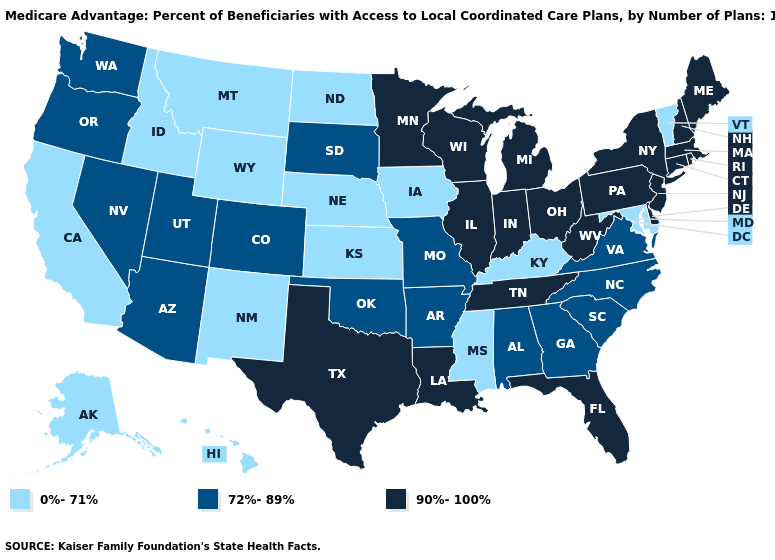What is the lowest value in states that border New Jersey?
Concise answer only. 90%-100%. Does Virginia have the highest value in the USA?
Be succinct. No. What is the highest value in states that border North Dakota?
Give a very brief answer. 90%-100%. Which states have the lowest value in the West?
Keep it brief. Alaska, California, Hawaii, Idaho, Montana, New Mexico, Wyoming. What is the lowest value in the MidWest?
Give a very brief answer. 0%-71%. Name the states that have a value in the range 72%-89%?
Answer briefly. Alabama, Arizona, Arkansas, Colorado, Georgia, Missouri, Nevada, North Carolina, Oklahoma, Oregon, South Carolina, South Dakota, Utah, Virginia, Washington. Among the states that border South Dakota , does Minnesota have the highest value?
Keep it brief. Yes. What is the value of New Jersey?
Keep it brief. 90%-100%. Does Maryland have the lowest value in the South?
Concise answer only. Yes. Does California have the highest value in the USA?
Keep it brief. No. Name the states that have a value in the range 0%-71%?
Concise answer only. Alaska, California, Hawaii, Idaho, Iowa, Kansas, Kentucky, Maryland, Mississippi, Montana, Nebraska, New Mexico, North Dakota, Vermont, Wyoming. Name the states that have a value in the range 0%-71%?
Write a very short answer. Alaska, California, Hawaii, Idaho, Iowa, Kansas, Kentucky, Maryland, Mississippi, Montana, Nebraska, New Mexico, North Dakota, Vermont, Wyoming. What is the value of Wyoming?
Concise answer only. 0%-71%. What is the value of New Jersey?
Keep it brief. 90%-100%. 